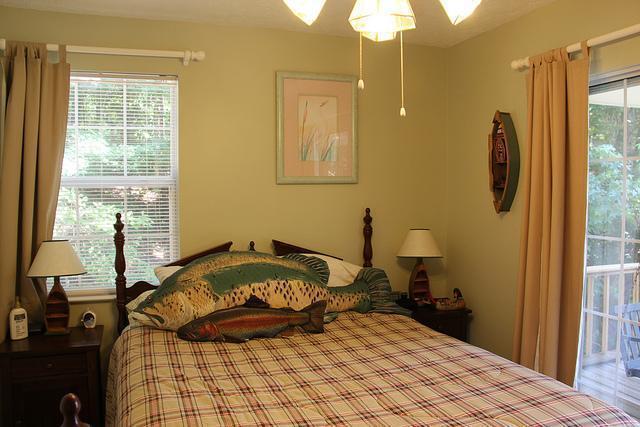What type of food is the animal on the bed classified as?
Pick the correct solution from the four options below to address the question.
Options: Seafood, beef, meat, legumes. Seafood. 